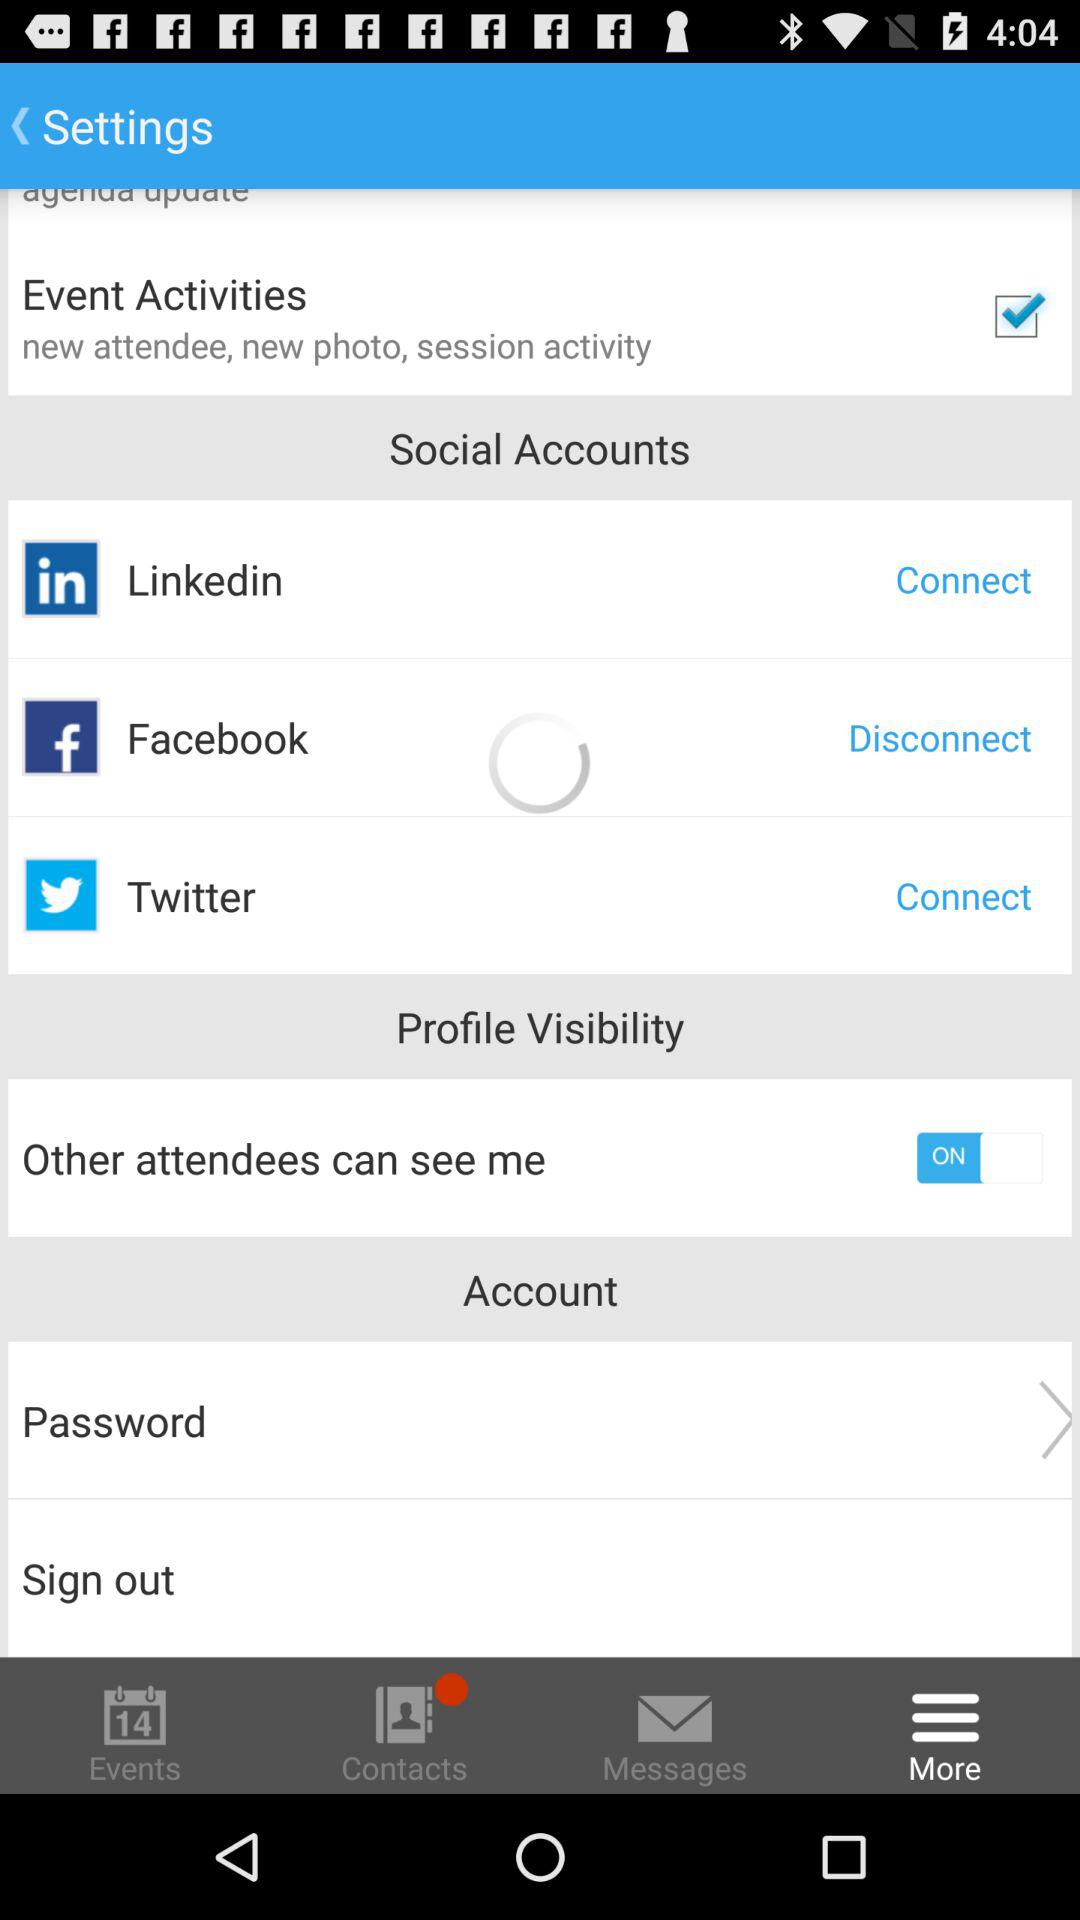Which option is marked as checked? The option that is marked as checked is "Event Activities". 